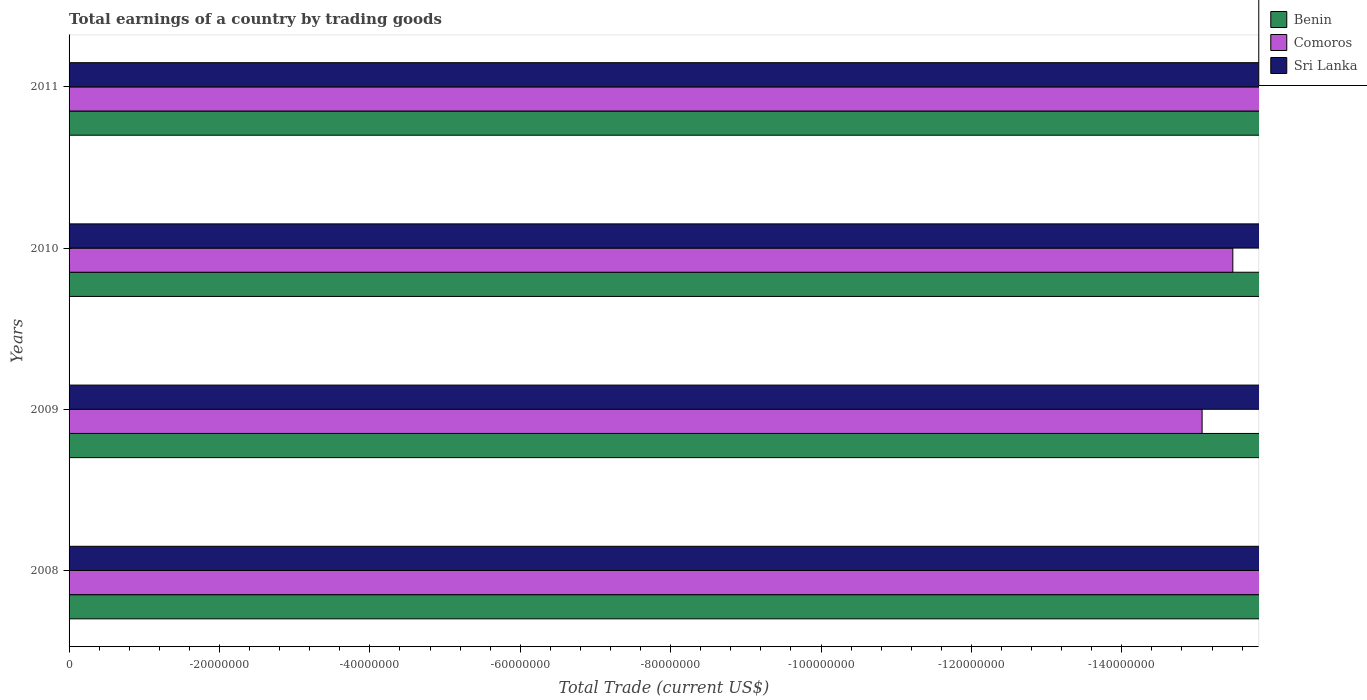How many different coloured bars are there?
Your answer should be compact. 0. How many bars are there on the 1st tick from the bottom?
Keep it short and to the point. 0. What is the label of the 4th group of bars from the top?
Offer a terse response. 2008. In how many cases, is the number of bars for a given year not equal to the number of legend labels?
Offer a terse response. 4. What is the total earnings in Benin in 2008?
Give a very brief answer. 0. What is the difference between the total earnings in Comoros in 2010 and the total earnings in Sri Lanka in 2009?
Provide a short and direct response. 0. What is the average total earnings in Comoros per year?
Offer a terse response. 0. How many bars are there?
Your answer should be compact. 0. Are the values on the major ticks of X-axis written in scientific E-notation?
Make the answer very short. No. Does the graph contain any zero values?
Offer a very short reply. Yes. Does the graph contain grids?
Your response must be concise. No. How many legend labels are there?
Provide a short and direct response. 3. How are the legend labels stacked?
Offer a terse response. Vertical. What is the title of the graph?
Offer a very short reply. Total earnings of a country by trading goods. What is the label or title of the X-axis?
Ensure brevity in your answer.  Total Trade (current US$). What is the Total Trade (current US$) of Benin in 2008?
Ensure brevity in your answer.  0. What is the Total Trade (current US$) in Comoros in 2008?
Keep it short and to the point. 0. What is the Total Trade (current US$) in Sri Lanka in 2008?
Make the answer very short. 0. What is the Total Trade (current US$) in Benin in 2009?
Your answer should be compact. 0. What is the Total Trade (current US$) of Comoros in 2009?
Provide a succinct answer. 0. What is the Total Trade (current US$) in Comoros in 2010?
Your answer should be compact. 0. What is the Total Trade (current US$) of Benin in 2011?
Ensure brevity in your answer.  0. What is the total Total Trade (current US$) of Sri Lanka in the graph?
Offer a terse response. 0. What is the average Total Trade (current US$) of Comoros per year?
Make the answer very short. 0. 